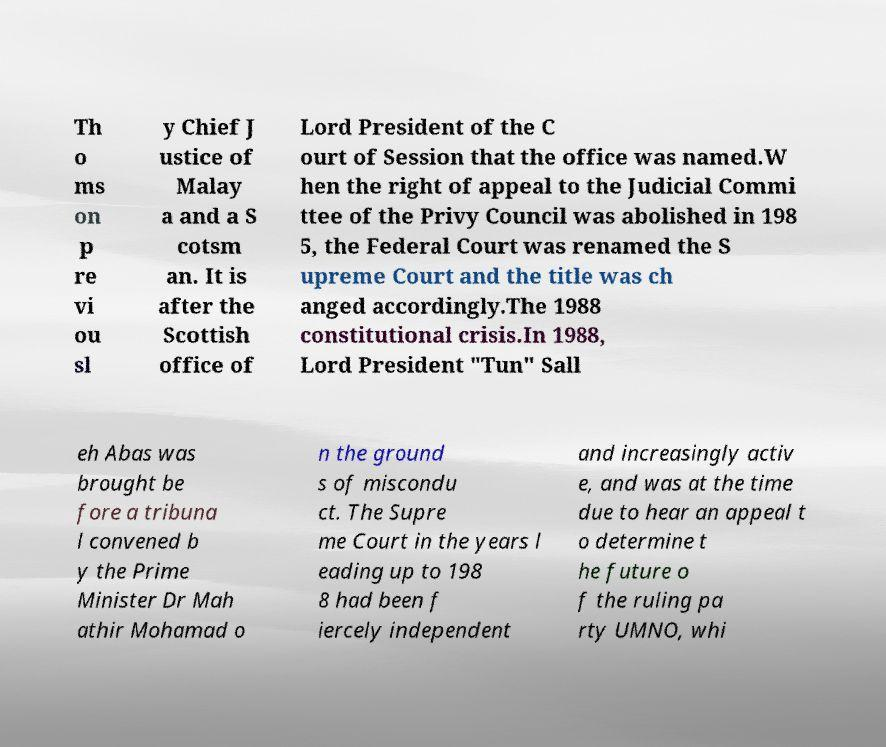Can you read and provide the text displayed in the image?This photo seems to have some interesting text. Can you extract and type it out for me? Th o ms on p re vi ou sl y Chief J ustice of Malay a and a S cotsm an. It is after the Scottish office of Lord President of the C ourt of Session that the office was named.W hen the right of appeal to the Judicial Commi ttee of the Privy Council was abolished in 198 5, the Federal Court was renamed the S upreme Court and the title was ch anged accordingly.The 1988 constitutional crisis.In 1988, Lord President "Tun" Sall eh Abas was brought be fore a tribuna l convened b y the Prime Minister Dr Mah athir Mohamad o n the ground s of miscondu ct. The Supre me Court in the years l eading up to 198 8 had been f iercely independent and increasingly activ e, and was at the time due to hear an appeal t o determine t he future o f the ruling pa rty UMNO, whi 